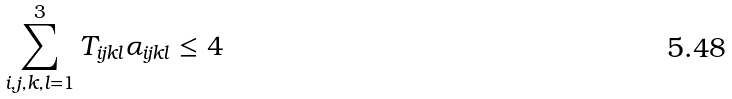<formula> <loc_0><loc_0><loc_500><loc_500>\sum _ { i , j , k , l = 1 } ^ { 3 } T _ { i j k l } \alpha _ { i j k l } \leq 4</formula> 